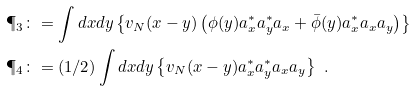Convert formula to latex. <formula><loc_0><loc_0><loc_500><loc_500>\P _ { 3 } & \colon = \int d x d y \left \{ v _ { N } ( x - y ) \left ( \phi ( y ) a ^ { \ast } _ { x } a ^ { \ast } _ { y } a _ { x } + \bar { \phi } ( y ) a ^ { \ast } _ { x } a _ { x } a _ { y } \right ) \right \} \\ \P _ { 4 } & \colon = ( 1 / 2 ) \int d x d y \left \{ v _ { N } ( x - y ) a ^ { \ast } _ { x } a ^ { \ast } _ { y } a _ { x } a _ { y } \right \} \ .</formula> 